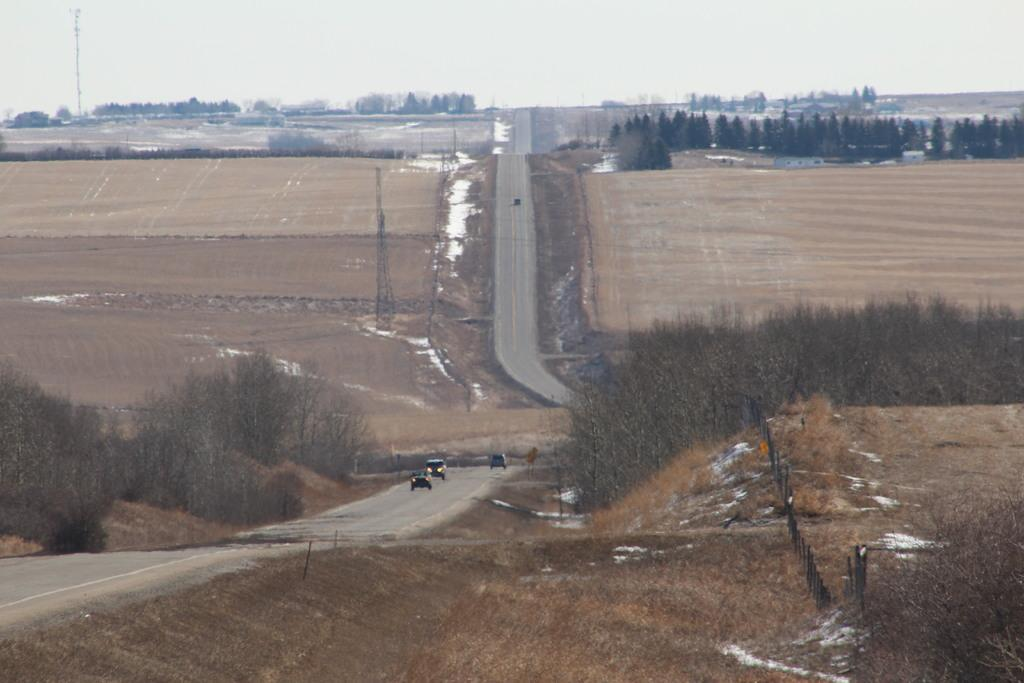What is located in the center of the image? There are cars in the center of the image. What type of pathway is visible in the image? There is a road in the image. What structure can be seen in the image? There is a tower in the image. What type of surface is visible in the image? There is ground visible in the image. What type of vegetation is present in the image? There are trees in the image. What is visible at the top of the image? The sky is visible at the top of the image. Where is the crayon located in the image? There is no crayon present in the image. What type of underwear is hanging on the tower in the image? There is no underwear present in the image, and the tower is not associated with any clothing items. 